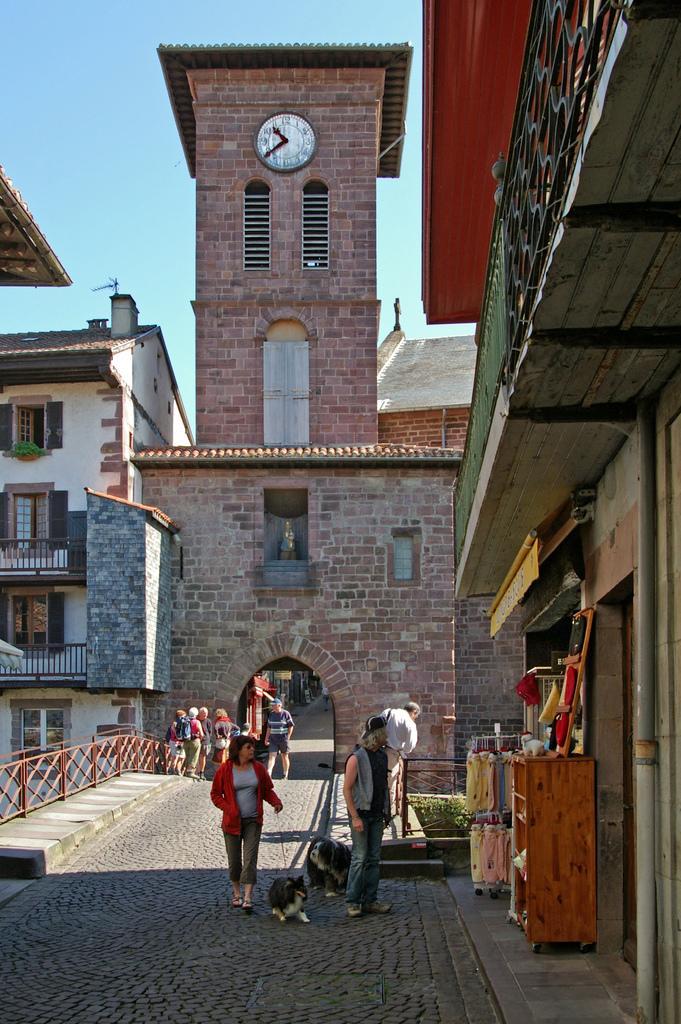Describe this image in one or two sentences. This is the picture of the outside of the city. We can in the background there is a stone wall bricks,sky,buildings and clock tower. In the center we have a woman. She is wearing red jacket. She is walking on a road. 